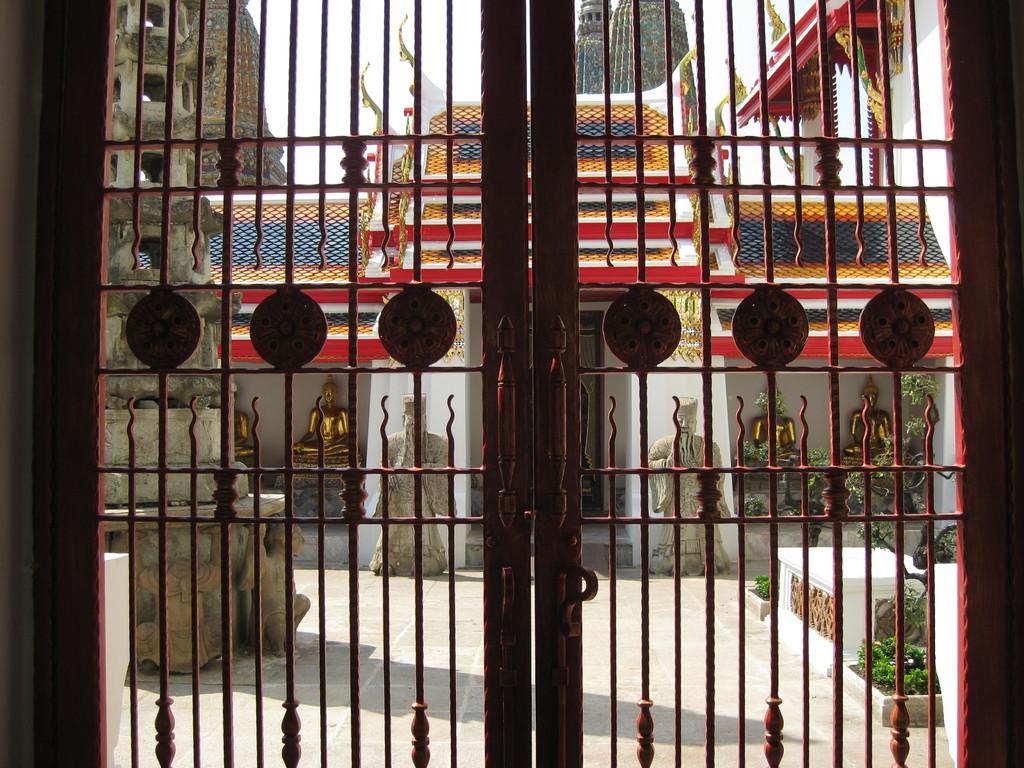In one or two sentences, can you explain what this image depicts? It looks like some temple, it is closed and behind the doors there are some sculptures and carvings done to the walls of the temple. 